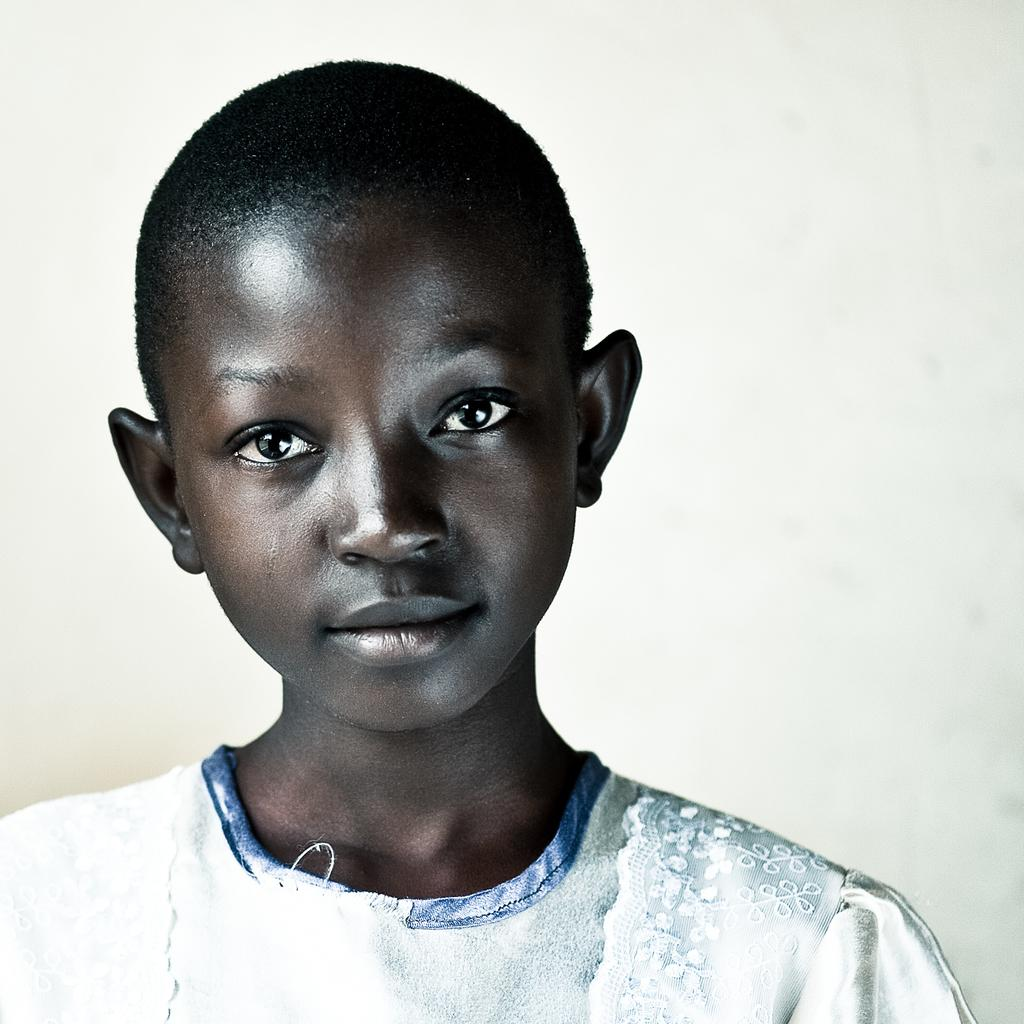What is the main subject of the image? There is a person in the image. What is the person wearing? The person is wearing a white dress. What can be seen in the background of the image? The background of the image is white. How many hydrants are visible in the image? There are no hydrants present in the image. What type of breath does the person have in the image? There is no indication of the person's breath in the image. 